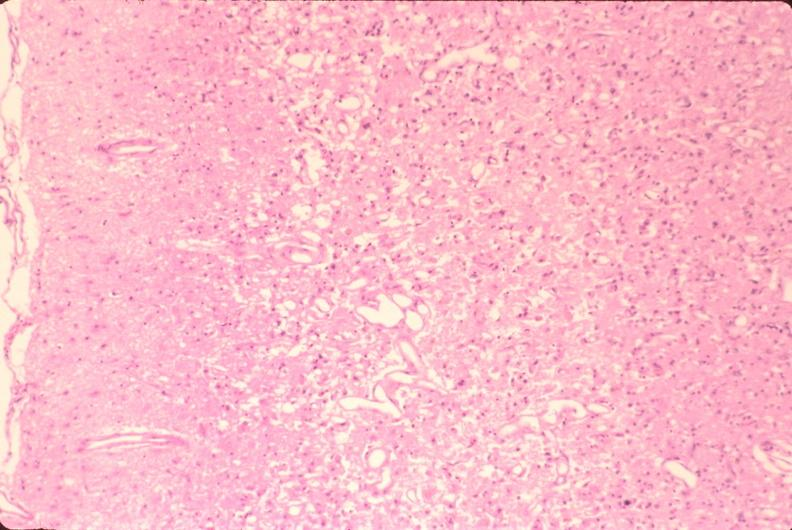s cm present?
Answer the question using a single word or phrase. No 